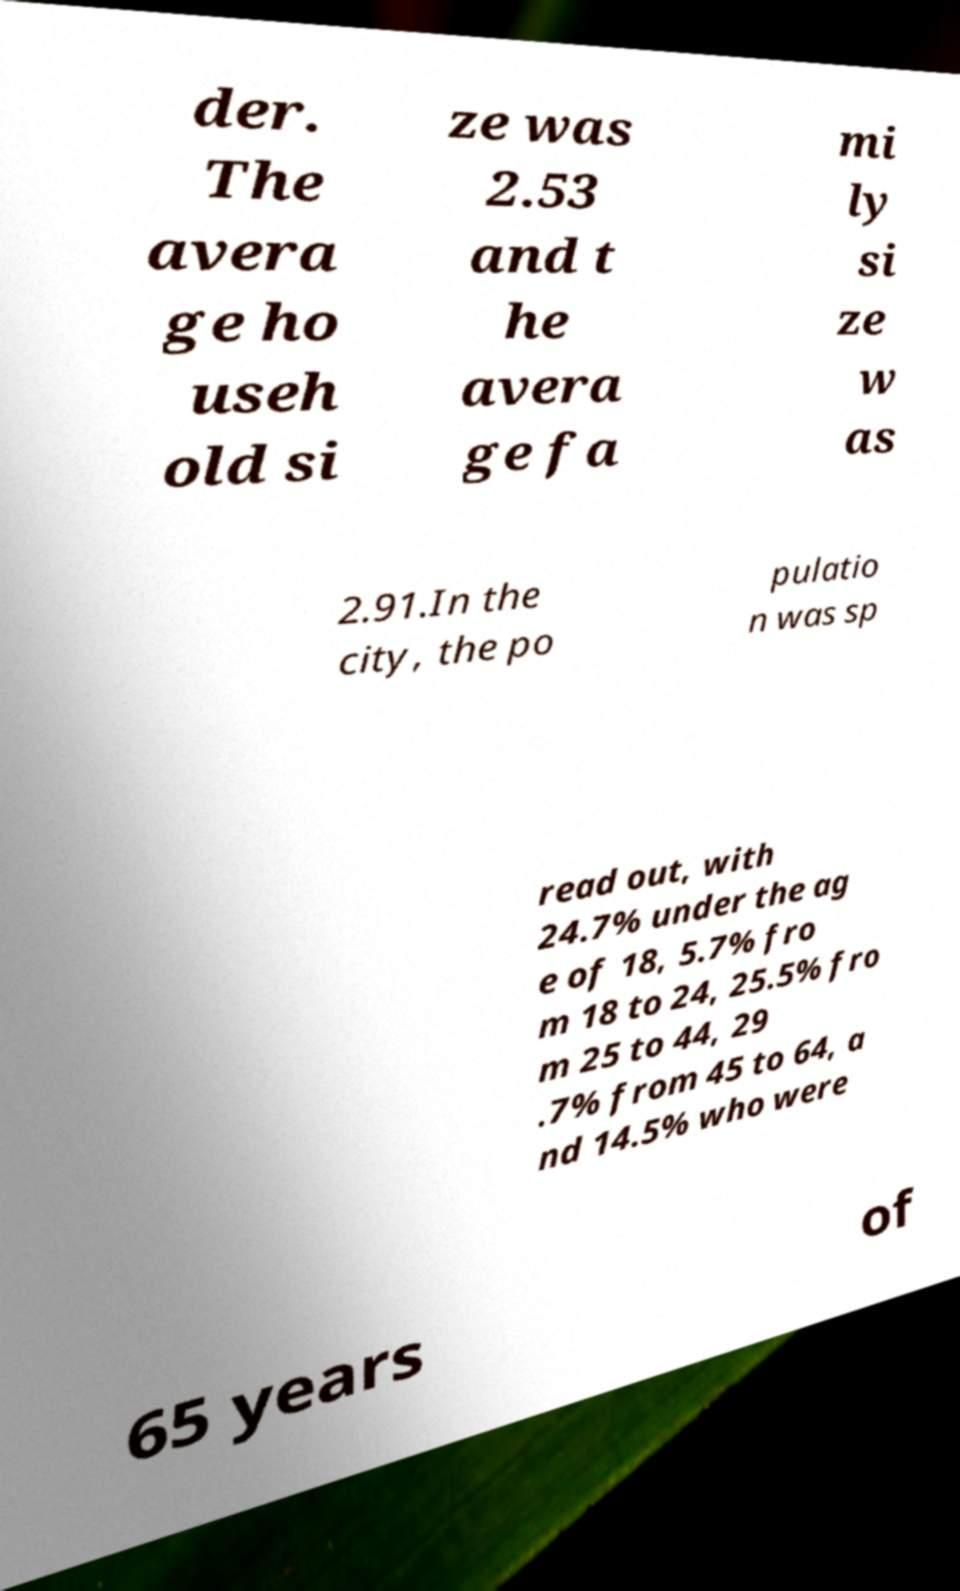There's text embedded in this image that I need extracted. Can you transcribe it verbatim? der. The avera ge ho useh old si ze was 2.53 and t he avera ge fa mi ly si ze w as 2.91.In the city, the po pulatio n was sp read out, with 24.7% under the ag e of 18, 5.7% fro m 18 to 24, 25.5% fro m 25 to 44, 29 .7% from 45 to 64, a nd 14.5% who were 65 years of 